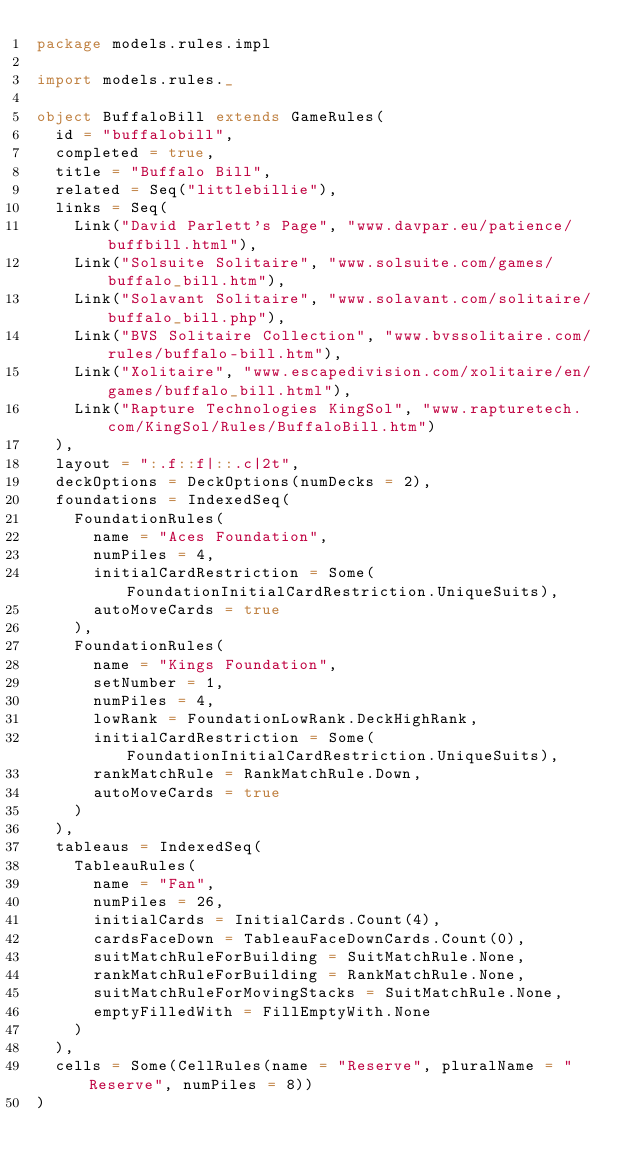Convert code to text. <code><loc_0><loc_0><loc_500><loc_500><_Scala_>package models.rules.impl

import models.rules._

object BuffaloBill extends GameRules(
  id = "buffalobill",
  completed = true,
  title = "Buffalo Bill",
  related = Seq("littlebillie"),
  links = Seq(
    Link("David Parlett's Page", "www.davpar.eu/patience/buffbill.html"),
    Link("Solsuite Solitaire", "www.solsuite.com/games/buffalo_bill.htm"),
    Link("Solavant Solitaire", "www.solavant.com/solitaire/buffalo_bill.php"),
    Link("BVS Solitaire Collection", "www.bvssolitaire.com/rules/buffalo-bill.htm"),
    Link("Xolitaire", "www.escapedivision.com/xolitaire/en/games/buffalo_bill.html"),
    Link("Rapture Technologies KingSol", "www.rapturetech.com/KingSol/Rules/BuffaloBill.htm")
  ),
  layout = ":.f::f|::.c|2t",
  deckOptions = DeckOptions(numDecks = 2),
  foundations = IndexedSeq(
    FoundationRules(
      name = "Aces Foundation",
      numPiles = 4,
      initialCardRestriction = Some(FoundationInitialCardRestriction.UniqueSuits),
      autoMoveCards = true
    ),
    FoundationRules(
      name = "Kings Foundation",
      setNumber = 1,
      numPiles = 4,
      lowRank = FoundationLowRank.DeckHighRank,
      initialCardRestriction = Some(FoundationInitialCardRestriction.UniqueSuits),
      rankMatchRule = RankMatchRule.Down,
      autoMoveCards = true
    )
  ),
  tableaus = IndexedSeq(
    TableauRules(
      name = "Fan",
      numPiles = 26,
      initialCards = InitialCards.Count(4),
      cardsFaceDown = TableauFaceDownCards.Count(0),
      suitMatchRuleForBuilding = SuitMatchRule.None,
      rankMatchRuleForBuilding = RankMatchRule.None,
      suitMatchRuleForMovingStacks = SuitMatchRule.None,
      emptyFilledWith = FillEmptyWith.None
    )
  ),
  cells = Some(CellRules(name = "Reserve", pluralName = "Reserve", numPiles = 8))
)
</code> 